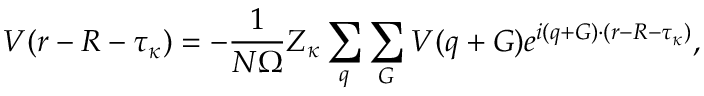Convert formula to latex. <formula><loc_0><loc_0><loc_500><loc_500>V ( r - R - \tau _ { \kappa } ) = - \frac { 1 } { N \Omega } Z _ { \kappa } \sum _ { q } \sum _ { G } V ( q + G ) e ^ { i ( q + G ) \cdot ( r - R - \tau _ { \kappa } ) } ,</formula> 